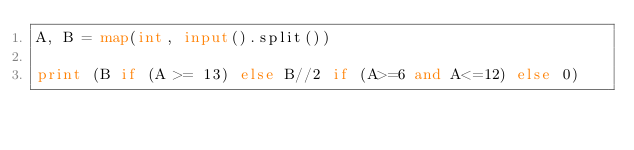<code> <loc_0><loc_0><loc_500><loc_500><_Python_>A, B = map(int, input().split())

print (B if (A >= 13) else B//2 if (A>=6 and A<=12) else 0)</code> 